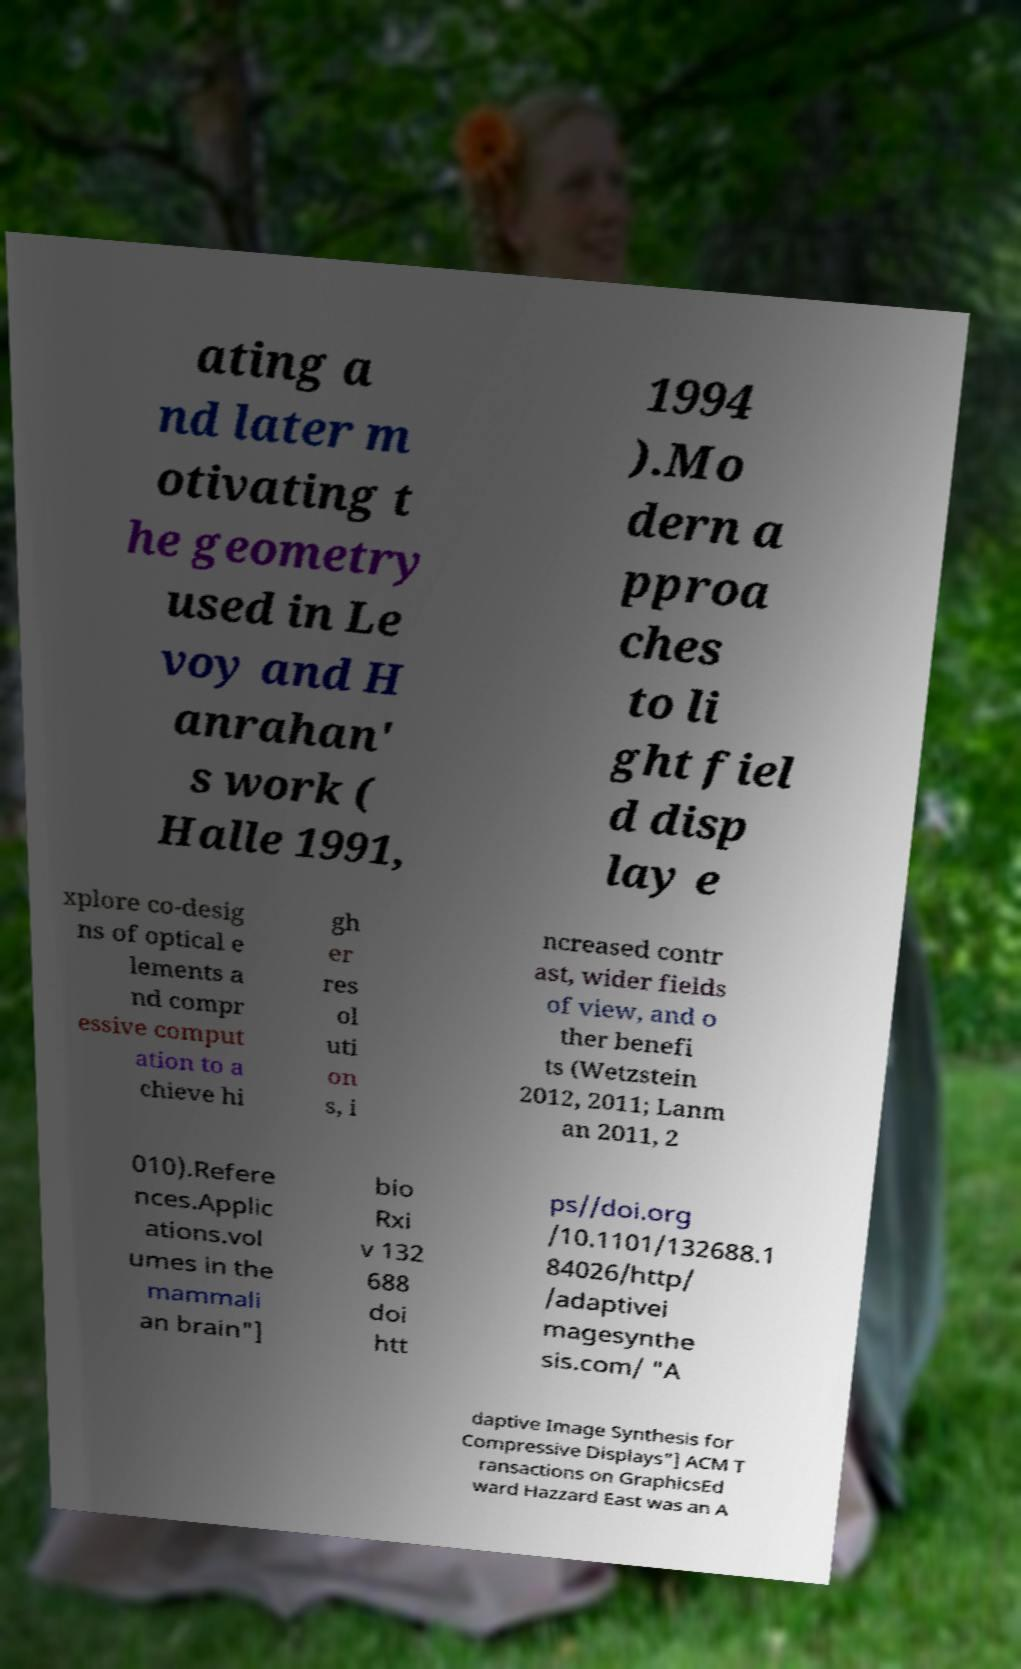What messages or text are displayed in this image? I need them in a readable, typed format. ating a nd later m otivating t he geometry used in Le voy and H anrahan' s work ( Halle 1991, 1994 ).Mo dern a pproa ches to li ght fiel d disp lay e xplore co-desig ns of optical e lements a nd compr essive comput ation to a chieve hi gh er res ol uti on s, i ncreased contr ast, wider fields of view, and o ther benefi ts (Wetzstein 2012, 2011; Lanm an 2011, 2 010).Refere nces.Applic ations.vol umes in the mammali an brain"] bio Rxi v 132 688 doi htt ps//doi.org /10.1101/132688.1 84026/http/ /adaptivei magesynthe sis.com/ "A daptive Image Synthesis for Compressive Displays"] ACM T ransactions on GraphicsEd ward Hazzard East was an A 